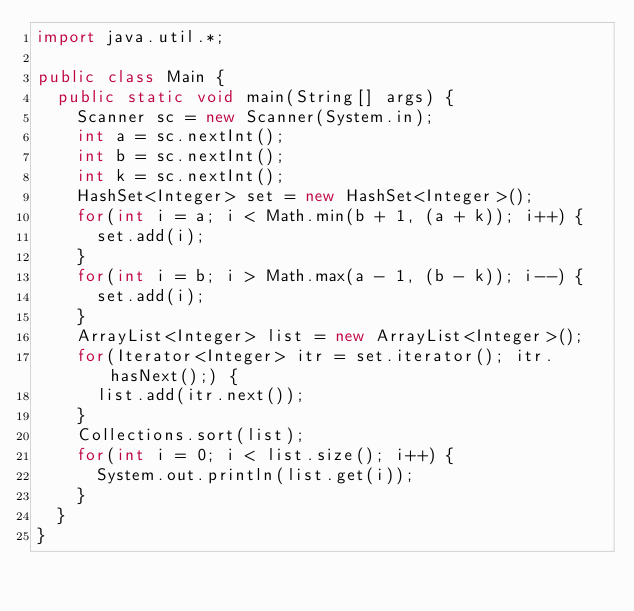<code> <loc_0><loc_0><loc_500><loc_500><_Java_>import java.util.*;

public class Main {
  public static void main(String[] args) {
    Scanner sc = new Scanner(System.in);
    int a = sc.nextInt();
    int b = sc.nextInt();
    int k = sc.nextInt();
    HashSet<Integer> set = new HashSet<Integer>();
    for(int i = a; i < Math.min(b + 1, (a + k)); i++) {
      set.add(i);
    }
    for(int i = b; i > Math.max(a - 1, (b - k)); i--) {
      set.add(i);
    }
    ArrayList<Integer> list = new ArrayList<Integer>();
    for(Iterator<Integer> itr = set.iterator(); itr.hasNext();) {
      list.add(itr.next());
    }
    Collections.sort(list);
    for(int i = 0; i < list.size(); i++) {
      System.out.println(list.get(i));
    }
  }
}</code> 